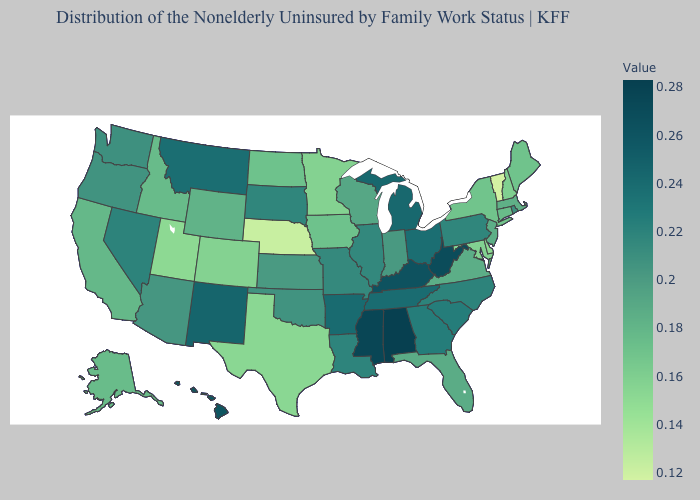Among the states that border Kansas , which have the highest value?
Keep it brief. Missouri. Among the states that border Arkansas , does Mississippi have the highest value?
Answer briefly. Yes. Among the states that border New York , does New Jersey have the highest value?
Give a very brief answer. No. Among the states that border Texas , which have the highest value?
Answer briefly. New Mexico. Does North Carolina have the highest value in the USA?
Give a very brief answer. No. 